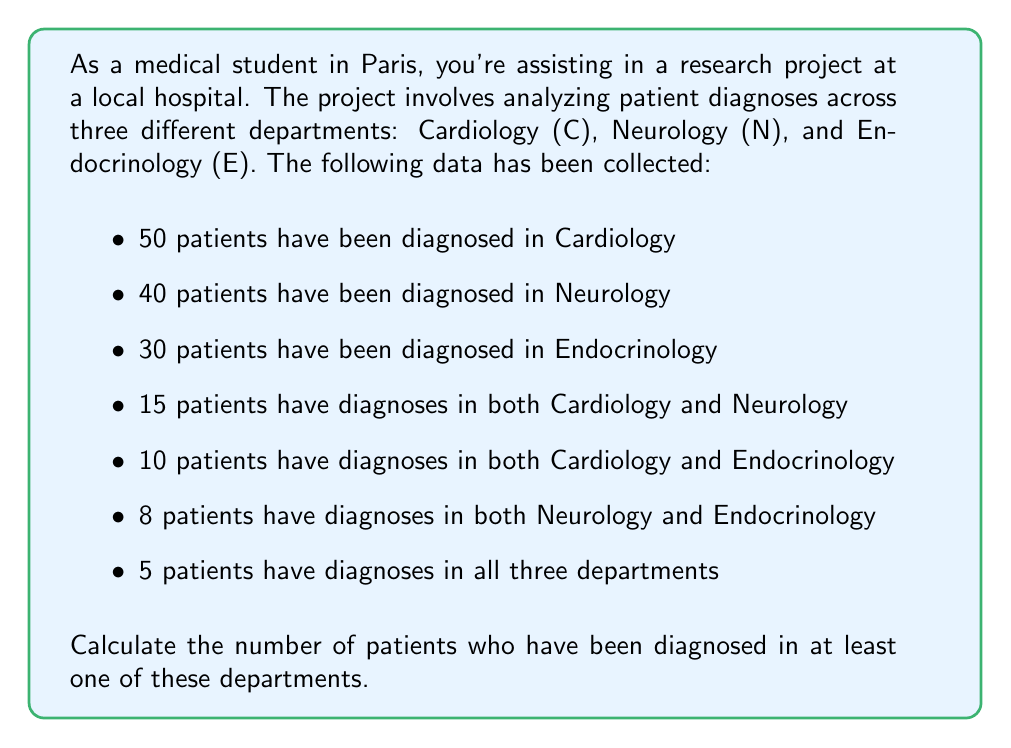Can you answer this question? To solve this problem, we'll use the principle of inclusion-exclusion for three sets. Let's define our sets:

$C$: patients diagnosed in Cardiology
$N$: patients diagnosed in Neurology
$E$: patients diagnosed in Endocrinology

The principle of inclusion-exclusion for three sets is given by:

$$|C \cup N \cup E| = |C| + |N| + |E| - |C \cap N| - |C \cap E| - |N \cap E| + |C \cap N \cap E|$$

Where:
$|C| = 50$
$|N| = 40$
$|E| = 30$
$|C \cap N| = 15$
$|C \cap E| = 10$
$|N \cap E| = 8$
$|C \cap N \cap E| = 5$

Now, let's substitute these values into our equation:

$$|C \cup N \cup E| = 50 + 40 + 30 - 15 - 10 - 8 + 5$$

Simplifying:

$$|C \cup N \cup E| = 120 - 33 + 5 = 92$$

Therefore, the number of patients diagnosed in at least one of these departments is 92.
Answer: 92 patients 